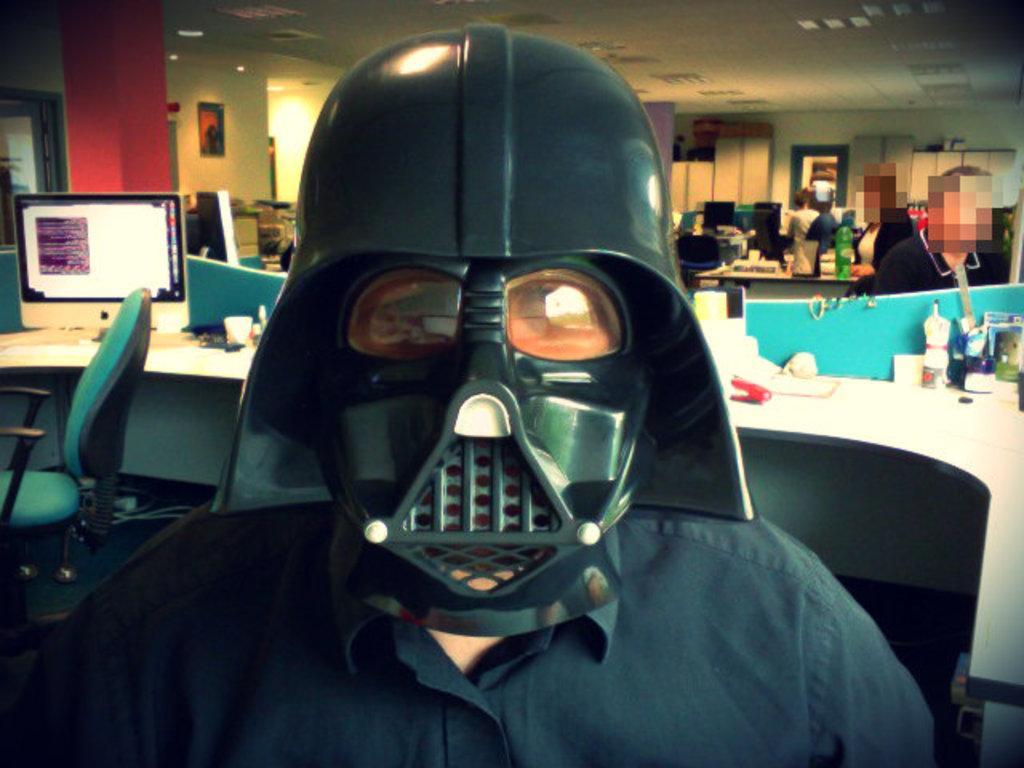In one or two sentences, can you explain what this image depicts? In this picture there is a person with helmet in the foreground. At the back there are tables and chairs and there are objects on the tables and there are computers on the tables and there are group of people and there is a frame on the wall. At the top there are lights. At the bottom there is a mat on the floor. 